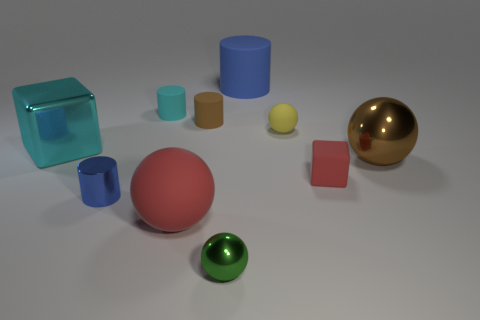What number of things are metallic cylinders or brown objects that are right of the brown matte cylinder?
Ensure brevity in your answer.  2. Are there any yellow matte balls that have the same size as the brown matte thing?
Your response must be concise. Yes. Are the tiny yellow object and the small block made of the same material?
Your answer should be compact. Yes. How many objects are tiny green shiny objects or small purple metallic blocks?
Give a very brief answer. 1. What is the size of the green thing?
Your answer should be compact. Small. Is the number of cyan metal cubes less than the number of tiny yellow metallic cubes?
Your answer should be compact. No. How many big shiny balls have the same color as the big rubber sphere?
Provide a short and direct response. 0. Do the large cube that is left of the tiny yellow matte sphere and the big cylinder have the same color?
Provide a succinct answer. No. There is a blue object in front of the brown rubber cylinder; what is its shape?
Provide a short and direct response. Cylinder. Is there a metal thing that is behind the red object that is to the left of the green shiny thing?
Provide a short and direct response. Yes. 